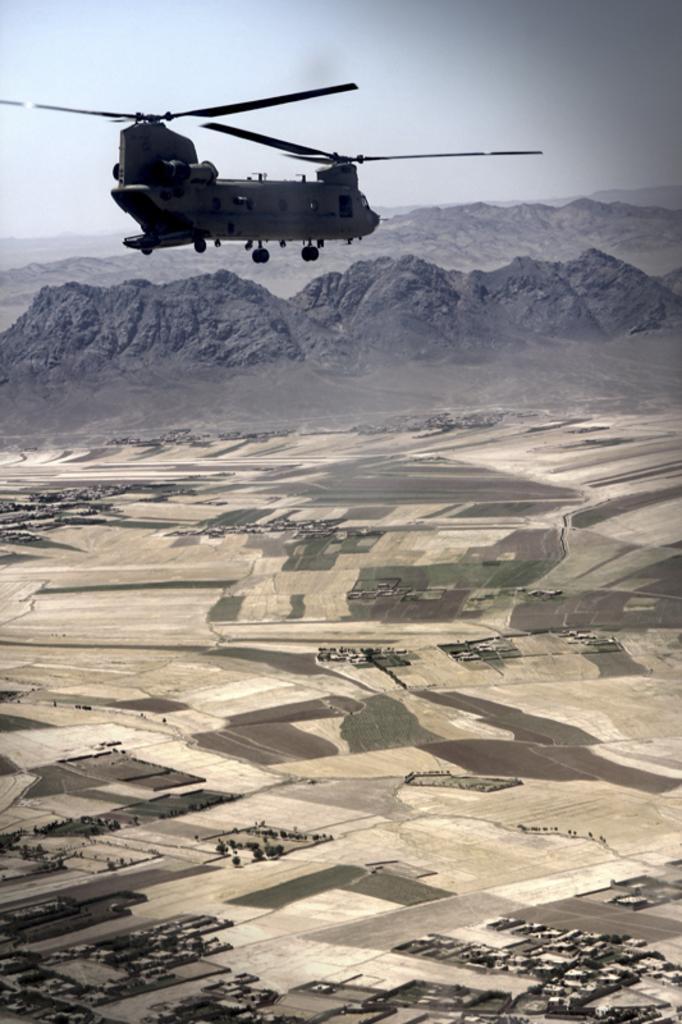Describe this image in one or two sentences. There is a helicopter flying in the air. Here we can see ground and a mountain. In the background there is sky. 